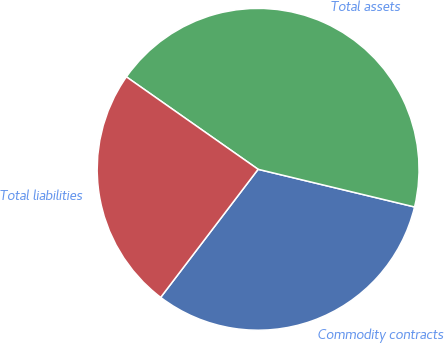<chart> <loc_0><loc_0><loc_500><loc_500><pie_chart><fcel>Commodity contracts<fcel>Total assets<fcel>Total liabilities<nl><fcel>31.59%<fcel>44.02%<fcel>24.39%<nl></chart> 